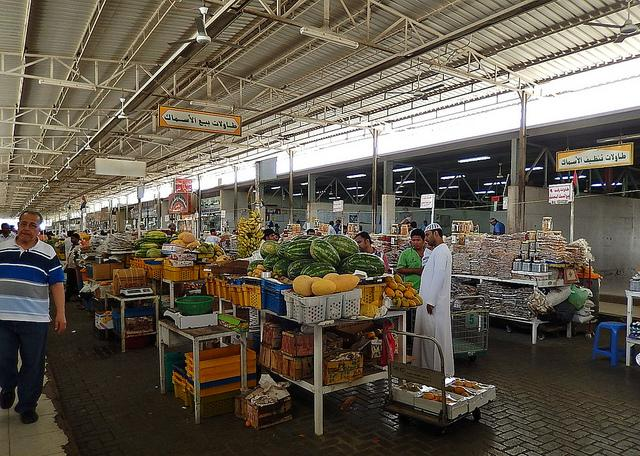What part of the market is located here?

Choices:
A) fruit stand
B) custom packaging
C) home wares
D) butcher fruit stand 